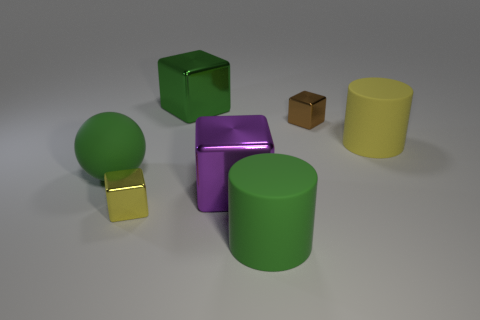Which object stands out the most to you and why? The purple metallic cube stands out the most due to its reflective surface that catches the light, creating a bright highlight and making it visually distinct from the matte surfaces of the other objects. Does the light reflection tell us anything about the material or texture of the objects? Yes, the light reflection on the purple cube indicates that it has a highly polished surface, which suggests it's made of a metallic material. In contrast, the more diffused reflections and softer shadows on the green ball and green cube suggest these are made from materials with less specular qualities, like rubber or plastic. 